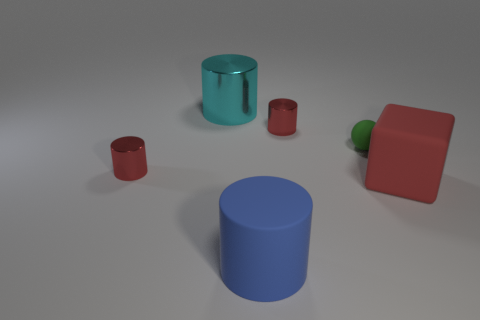What shape is the large red object?
Make the answer very short. Cube. Are there fewer large shiny things to the right of the blue matte thing than small cyan metal blocks?
Provide a succinct answer. No. Is there a large matte thing of the same shape as the cyan metallic object?
Give a very brief answer. Yes. The red rubber thing that is the same size as the blue object is what shape?
Provide a short and direct response. Cube. How many objects are yellow matte cylinders or green objects?
Make the answer very short. 1. Are any big blue metallic objects visible?
Make the answer very short. No. Are there fewer large cyan spheres than green objects?
Your answer should be compact. Yes. Are there any blocks that have the same size as the cyan metal object?
Your response must be concise. Yes. Is the shape of the big metal object the same as the red shiny thing that is behind the tiny green rubber thing?
Offer a very short reply. Yes. How many cylinders are either large matte objects or matte things?
Make the answer very short. 1. 